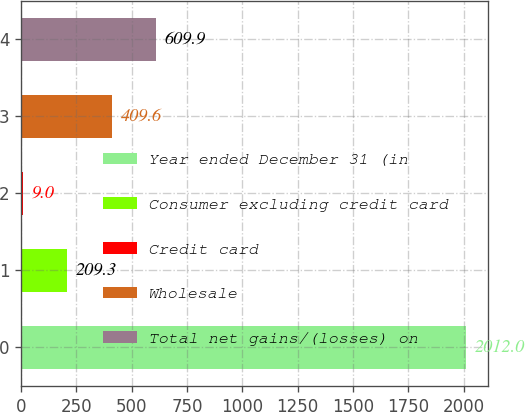Convert chart to OTSL. <chart><loc_0><loc_0><loc_500><loc_500><bar_chart><fcel>Year ended December 31 (in<fcel>Consumer excluding credit card<fcel>Credit card<fcel>Wholesale<fcel>Total net gains/(losses) on<nl><fcel>2012<fcel>209.3<fcel>9<fcel>409.6<fcel>609.9<nl></chart> 